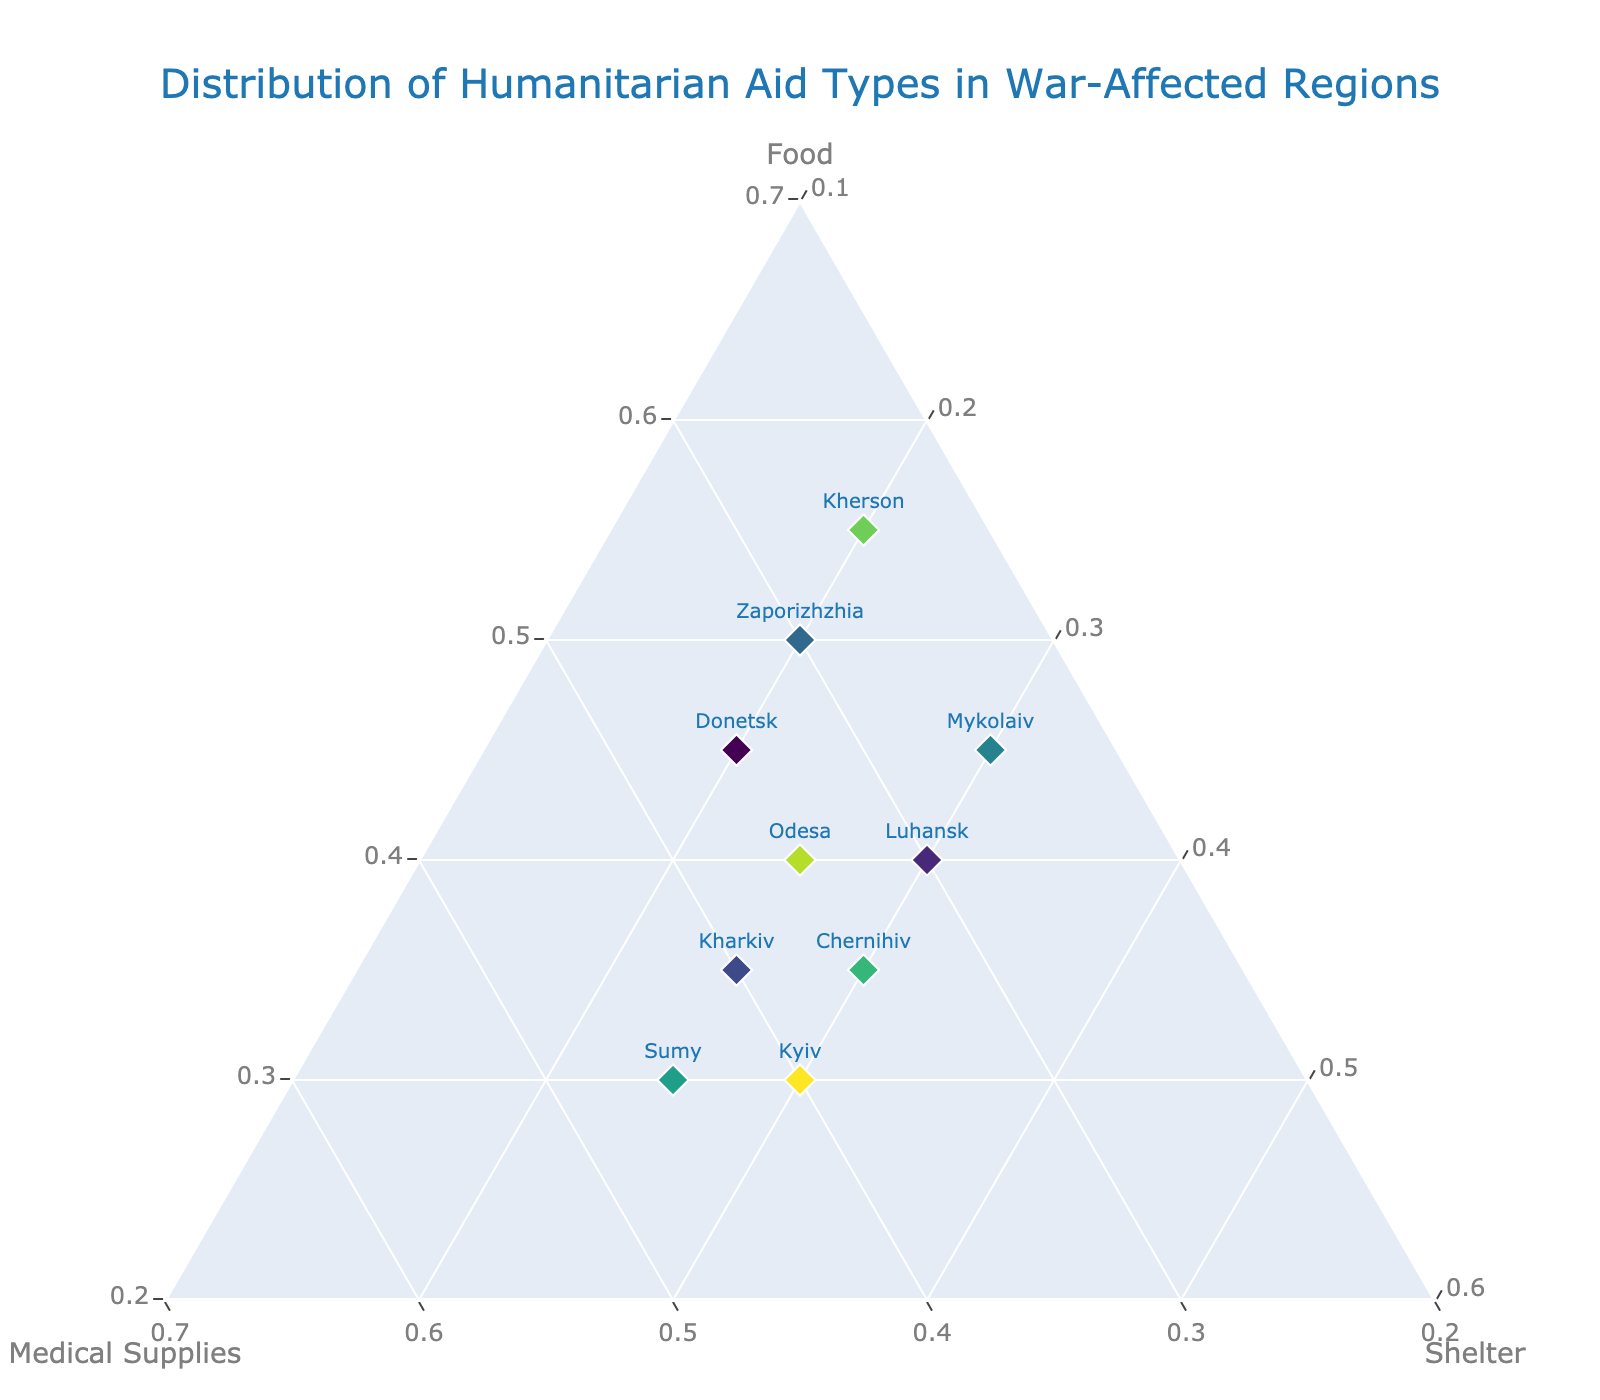Which region receives the highest proportion of medical supplies? Look at the axes that denote the proportion of medical supplies (b-axis) and identify which region's marker is closest to the maximum value on that axis. Sumy, with 0.45, receives the highest proportion.
Answer: Sumy Which region receives the least shelter aid? Look at the axes denoting the proportion of shelter (c-axis) and identify which region's marker is closest to the minimum value on that axis. Donetsk and Kherson both have the smallest share of shelter aid, at 0.20.
Answer: Donetsk/Kyiv Which regions have an equal proportion of medical supplies and shelter? Look at the a-axis and b-axis values to identify regions where the proportions of medical supplies and shelter are the same. In this case, no region has equal values for medical supplies and shelter.
Answer: None What is the average proportion of food aid for all regions? Sum the proportions of food aid for all regions and divide by the number of regions: (0.45 + 0.40 + 0.35 + 0.50 + 0.45 + 0.30 + 0.35 + 0.55 + 0.40 + 0.30) / 10 = 4.05 / 10 = 0.405.
Answer: 0.405 Which region receives more than 0.4 proportion of food aid but less than 0.3 proportion of medical supplies? Identify the food aid and medical supplies proportions for all regions. Kherson receives 0.55 food aid and 0.25 medical supplies.
Answer: Kherson What's the difference in the proportion of shelter aid between Mykolaiv and Chernihiv? Subtract the shelter aid proportion of Chernihiv from Mykolaiv: 0.30 - 0.30 = 0.
Answer: 0 Between Luhansk and Kharkiv, which region receives a higher proportion of shelter aid? Compare the shelter aid proportions: Luhansk receives 0.30 while Kharkiv receives 0.25. Luhansk receives more shelter aid.
Answer: Luhansk Which two regions have received the same proportion of medical supplies? Identify the regions with identical medical supplies proportions. Donetsk and Odesa both receive 0.35.
Answer: Donetsk, Odesa 